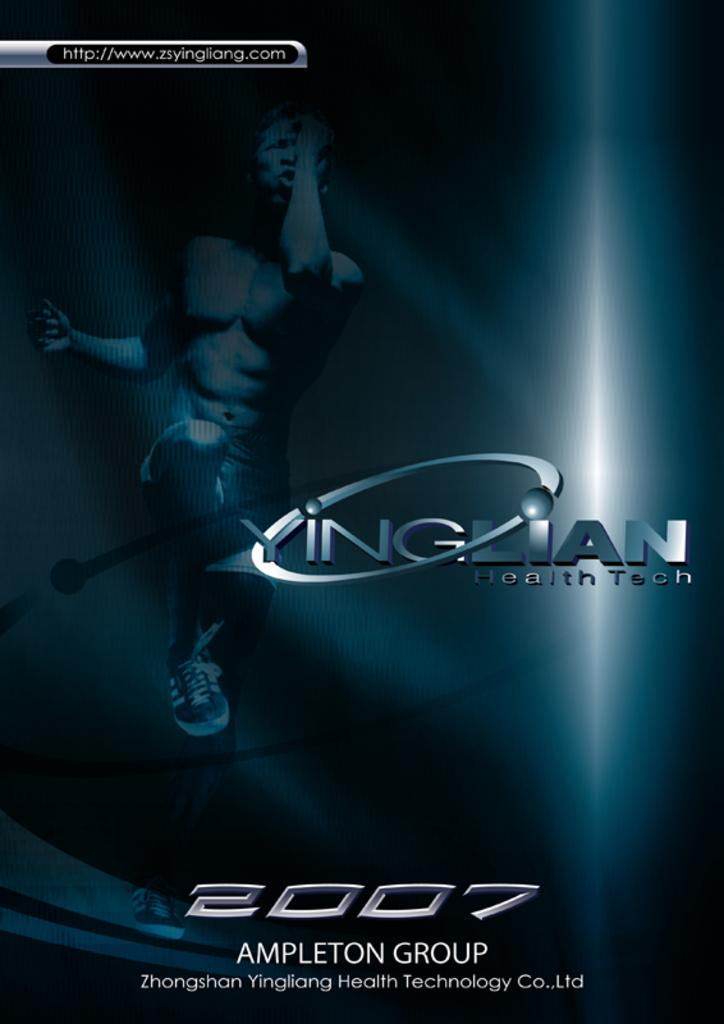Provide a one-sentence caption for the provided image. Yinglian health tech 2008 poster from the Ampleton Group. 